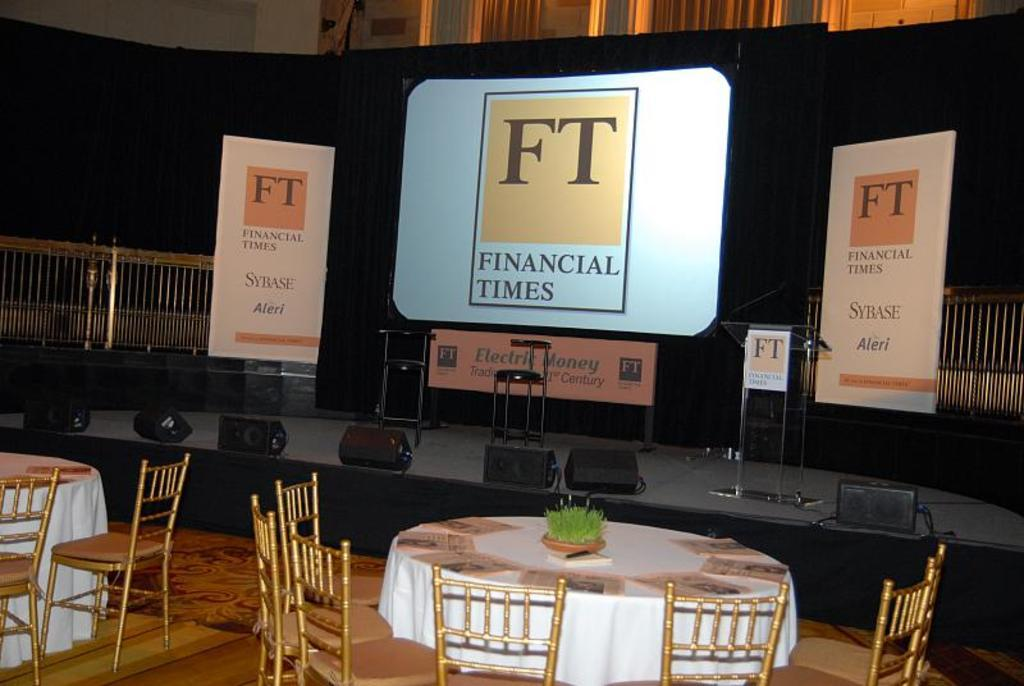<image>
Summarize the visual content of the image. A screen on a stage in front of round dining tables saying FT Financial Times. 